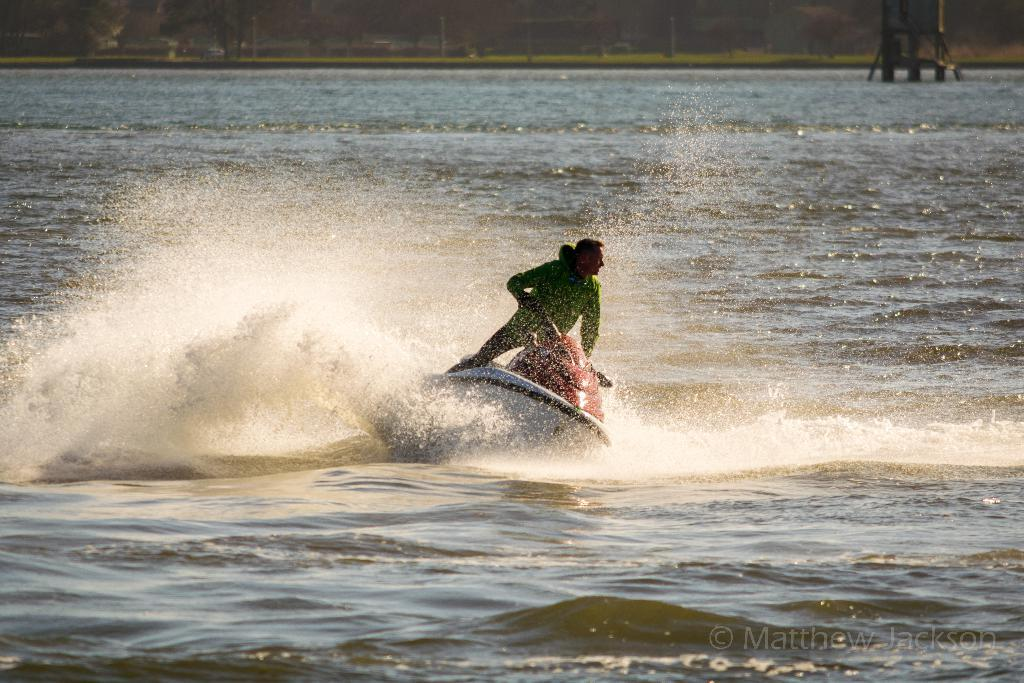What is the person in the image doing? There is a person riding a speed boat in the image. What is the setting of the image? There is water visible at the bottom of the image, and there are trees and grass in the background. Where is the text located in the image? The text is at the right bottom of the image. What type of dust can be seen on the vessel in the image? There is no vessel or dust present in the image. What note is the person playing on the speed boat? There is no musical instrument or note being played in the image; the person is simply riding the speed boat. 